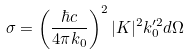Convert formula to latex. <formula><loc_0><loc_0><loc_500><loc_500>\sigma = \left ( \frac { \hbar { c } } { 4 \pi k _ { 0 } } \right ) ^ { 2 } | K | ^ { 2 } k _ { 0 } ^ { \prime 2 } d \Omega</formula> 